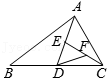Clarify your interpretation of the image. The diagram illustrates a triangle labeled ABC, with additional points D, E, and F positioned on the sides BC, AC, and AB respectively. This setup might suggest the study of triangle midsegments, point symmetry, or a particular theorem application such as Menelaus' or Ceva's theorem, which could relate to the ratios or properties connecting these points. Given the area of triangle ABC is 4 cm squared, each line segment or point could provide significant information in a geometric analysis. 